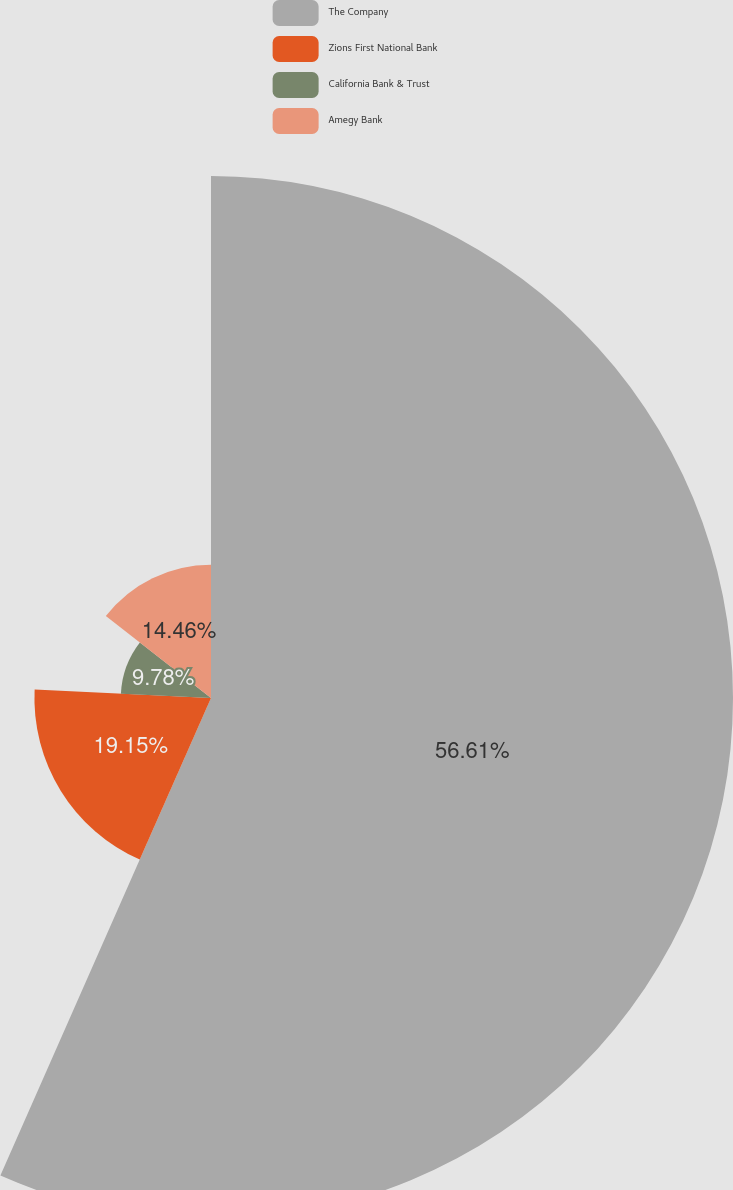Convert chart to OTSL. <chart><loc_0><loc_0><loc_500><loc_500><pie_chart><fcel>The Company<fcel>Zions First National Bank<fcel>California Bank & Trust<fcel>Amegy Bank<nl><fcel>56.61%<fcel>19.15%<fcel>9.78%<fcel>14.46%<nl></chart> 